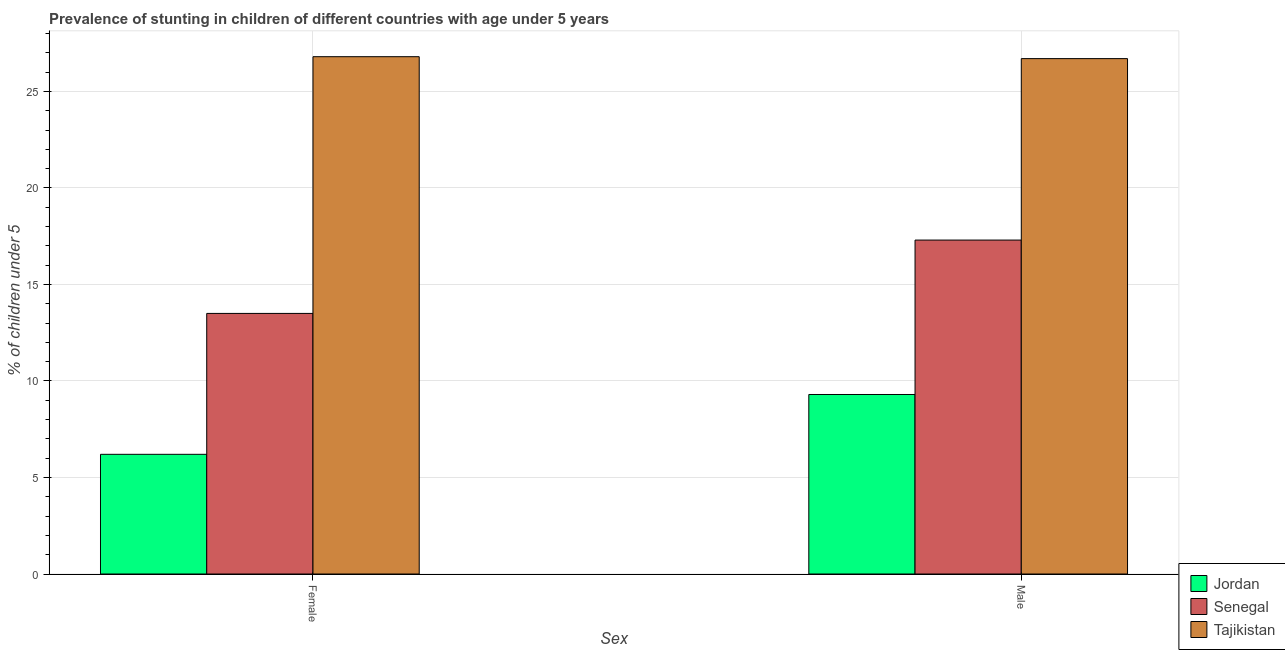How many different coloured bars are there?
Make the answer very short. 3. Are the number of bars per tick equal to the number of legend labels?
Your answer should be compact. Yes. How many bars are there on the 1st tick from the left?
Provide a short and direct response. 3. How many bars are there on the 1st tick from the right?
Your answer should be very brief. 3. What is the label of the 2nd group of bars from the left?
Make the answer very short. Male. What is the percentage of stunted male children in Senegal?
Keep it short and to the point. 17.3. Across all countries, what is the maximum percentage of stunted male children?
Provide a short and direct response. 26.7. Across all countries, what is the minimum percentage of stunted male children?
Offer a very short reply. 9.3. In which country was the percentage of stunted male children maximum?
Your answer should be compact. Tajikistan. In which country was the percentage of stunted female children minimum?
Ensure brevity in your answer.  Jordan. What is the total percentage of stunted female children in the graph?
Your answer should be very brief. 46.5. What is the difference between the percentage of stunted female children in Tajikistan and that in Senegal?
Your response must be concise. 13.3. What is the difference between the percentage of stunted female children in Jordan and the percentage of stunted male children in Senegal?
Give a very brief answer. -11.1. What is the average percentage of stunted female children per country?
Your answer should be very brief. 15.5. What is the difference between the percentage of stunted male children and percentage of stunted female children in Jordan?
Give a very brief answer. 3.1. What is the ratio of the percentage of stunted female children in Senegal to that in Tajikistan?
Make the answer very short. 0.5. Is the percentage of stunted female children in Jordan less than that in Tajikistan?
Keep it short and to the point. Yes. What does the 2nd bar from the left in Male represents?
Make the answer very short. Senegal. What does the 2nd bar from the right in Male represents?
Offer a terse response. Senegal. Does the graph contain any zero values?
Your answer should be very brief. No. Where does the legend appear in the graph?
Provide a short and direct response. Bottom right. What is the title of the graph?
Your answer should be compact. Prevalence of stunting in children of different countries with age under 5 years. Does "Philippines" appear as one of the legend labels in the graph?
Offer a terse response. No. What is the label or title of the X-axis?
Give a very brief answer. Sex. What is the label or title of the Y-axis?
Ensure brevity in your answer.   % of children under 5. What is the  % of children under 5 in Jordan in Female?
Provide a short and direct response. 6.2. What is the  % of children under 5 in Senegal in Female?
Your answer should be compact. 13.5. What is the  % of children under 5 of Tajikistan in Female?
Provide a succinct answer. 26.8. What is the  % of children under 5 in Jordan in Male?
Your answer should be compact. 9.3. What is the  % of children under 5 in Senegal in Male?
Your response must be concise. 17.3. What is the  % of children under 5 of Tajikistan in Male?
Provide a succinct answer. 26.7. Across all Sex, what is the maximum  % of children under 5 in Jordan?
Provide a succinct answer. 9.3. Across all Sex, what is the maximum  % of children under 5 of Senegal?
Keep it short and to the point. 17.3. Across all Sex, what is the maximum  % of children under 5 of Tajikistan?
Offer a very short reply. 26.8. Across all Sex, what is the minimum  % of children under 5 of Jordan?
Offer a terse response. 6.2. Across all Sex, what is the minimum  % of children under 5 of Tajikistan?
Your response must be concise. 26.7. What is the total  % of children under 5 in Jordan in the graph?
Your answer should be very brief. 15.5. What is the total  % of children under 5 in Senegal in the graph?
Offer a very short reply. 30.8. What is the total  % of children under 5 of Tajikistan in the graph?
Provide a succinct answer. 53.5. What is the difference between the  % of children under 5 in Tajikistan in Female and that in Male?
Your answer should be very brief. 0.1. What is the difference between the  % of children under 5 of Jordan in Female and the  % of children under 5 of Tajikistan in Male?
Offer a very short reply. -20.5. What is the difference between the  % of children under 5 of Senegal in Female and the  % of children under 5 of Tajikistan in Male?
Provide a succinct answer. -13.2. What is the average  % of children under 5 of Jordan per Sex?
Make the answer very short. 7.75. What is the average  % of children under 5 in Tajikistan per Sex?
Offer a terse response. 26.75. What is the difference between the  % of children under 5 in Jordan and  % of children under 5 in Tajikistan in Female?
Your answer should be very brief. -20.6. What is the difference between the  % of children under 5 of Senegal and  % of children under 5 of Tajikistan in Female?
Ensure brevity in your answer.  -13.3. What is the difference between the  % of children under 5 in Jordan and  % of children under 5 in Tajikistan in Male?
Keep it short and to the point. -17.4. What is the ratio of the  % of children under 5 in Jordan in Female to that in Male?
Offer a very short reply. 0.67. What is the ratio of the  % of children under 5 of Senegal in Female to that in Male?
Offer a very short reply. 0.78. What is the ratio of the  % of children under 5 in Tajikistan in Female to that in Male?
Offer a very short reply. 1. What is the difference between the highest and the second highest  % of children under 5 in Senegal?
Keep it short and to the point. 3.8. What is the difference between the highest and the lowest  % of children under 5 of Jordan?
Your answer should be very brief. 3.1. What is the difference between the highest and the lowest  % of children under 5 in Senegal?
Your answer should be compact. 3.8. What is the difference between the highest and the lowest  % of children under 5 of Tajikistan?
Offer a very short reply. 0.1. 